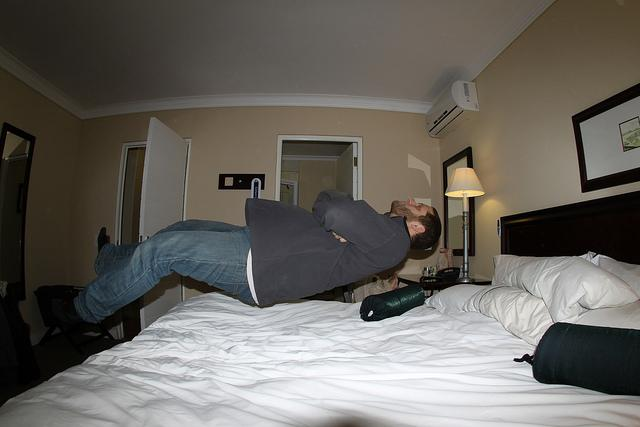The man here is posing to mimic what?

Choices:
A) drunkenness
B) levitation
C) working out
D) insomnia levitation 